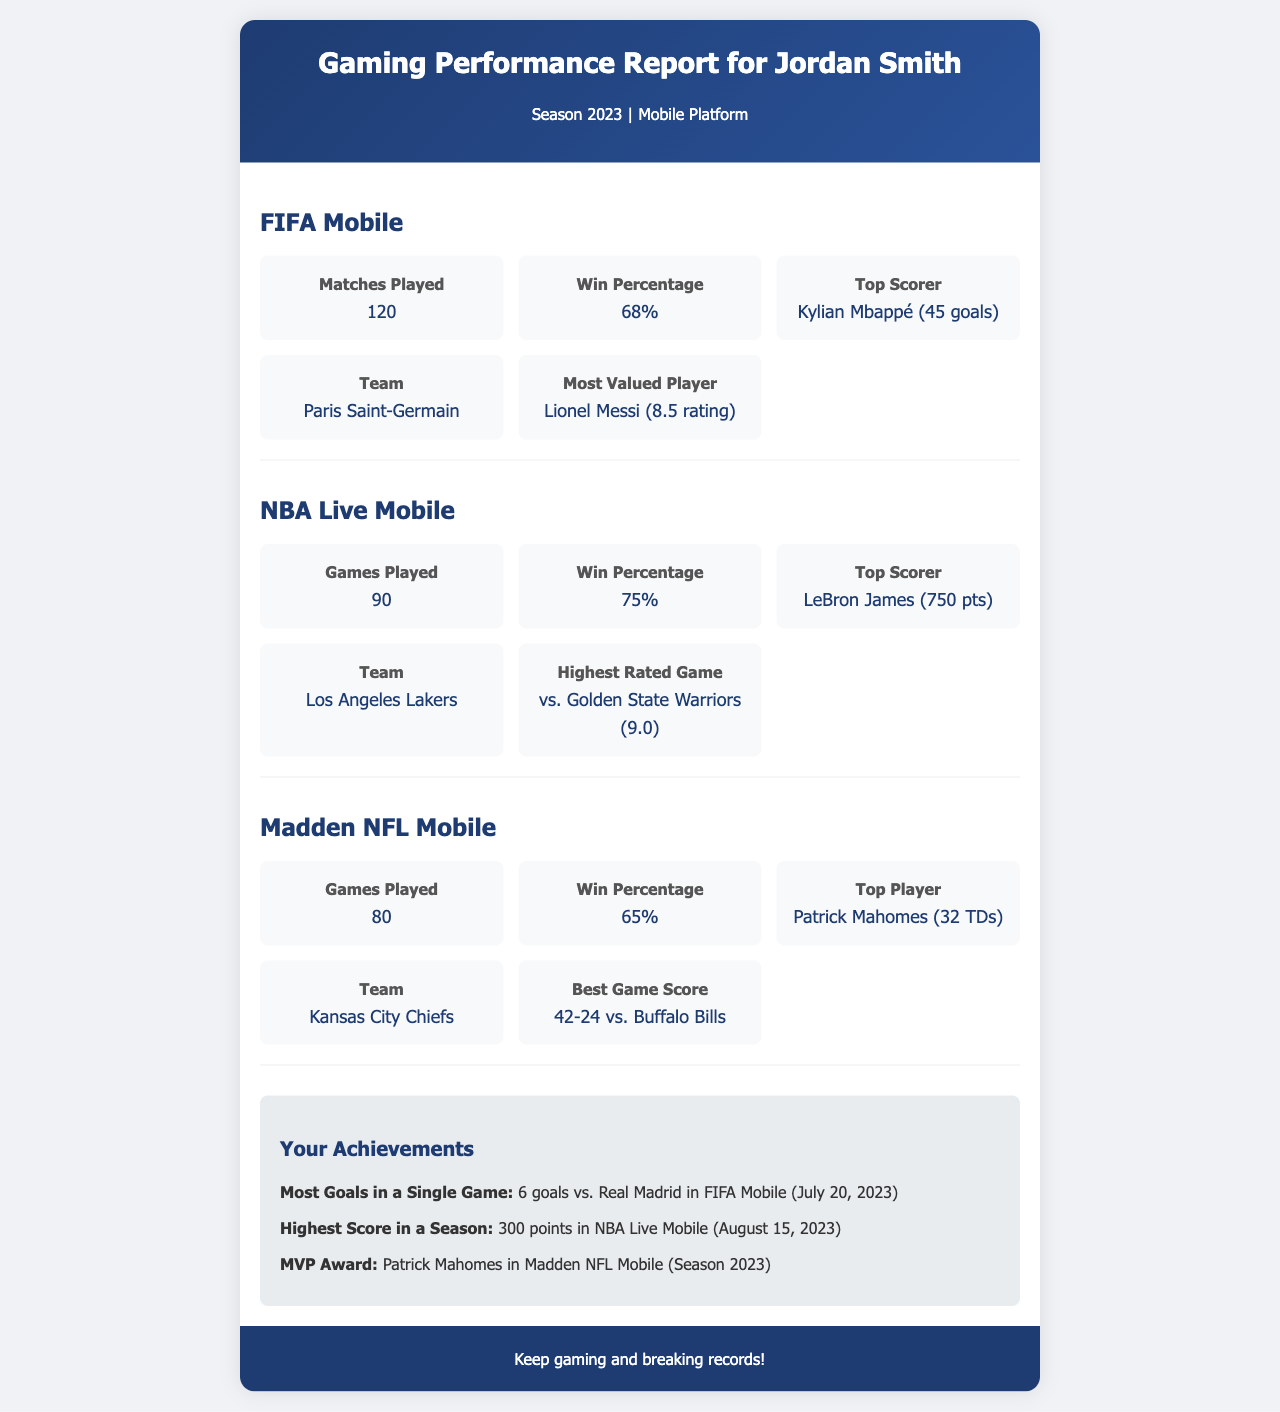What is the win percentage in FIFA Mobile? The win percentage in FIFA Mobile is provided in the statistics section, which states 68%.
Answer: 68% Who is the top scorer in NBA Live Mobile? The document lists LeBron James as the top scorer in NBA Live Mobile with 750 points.
Answer: LeBron James (750 pts) How many matches were played in Madden NFL Mobile? The total games played in Madden NFL Mobile is listed as 80.
Answer: 80 Which team did Jordan Smith represent in FIFA Mobile? The document indicates that Jordan Smith's team in FIFA Mobile is Paris Saint-Germain.
Answer: Paris Saint-Germain What is the highest rated game in NBA Live Mobile? The highest rated game is mentioned as the match against the Golden State Warriors, which had a rating of 9.0.
Answer: vs. Golden State Warriors (9.0) What achievement did Jordan Smith accomplish in FIFA Mobile? The document states that Jordan Smith scored 6 goals in a single game against Real Madrid as an achievement.
Answer: 6 goals vs. Real Madrid Which player was awarded MVP in Madden NFL Mobile? The document identifies Patrick Mahomes as the player awarded MVP in Madden NFL Mobile for Season 2023.
Answer: Patrick Mahomes What is the total number of achievements listed in the report? The report provides three specific achievements under the achievements section.
Answer: 3 Which game had the highest win percentage? The win percentages for FIFA Mobile, NBA Live Mobile, and Madden NFL Mobile are given, showing that NBA Live Mobile has the highest at 75%.
Answer: 75% What is the format of this document? The document is structured as a performance report specifically designed for gaming statistics and achievements.
Answer: Performance report 